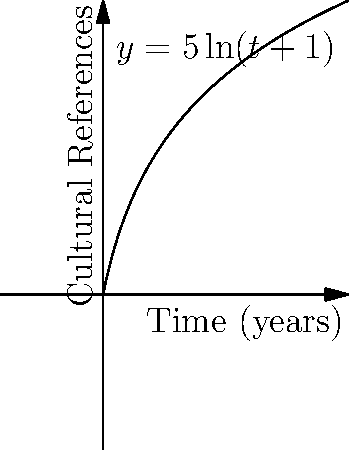In the context of film franchises, cultural references often accumulate over time. The function $y = 5\ln(t+1)$ represents the number of cultural references in a franchise, where $t$ is the time in years since the franchise's inception. Calculate the total accumulation of cultural references over the first 5 years of the franchise's existence. To find the total accumulation of cultural references over the first 5 years, we need to calculate the definite integral of the given function from $t=0$ to $t=5$.

1. The integral we need to evaluate is:
   $$\int_0^5 5\ln(t+1) dt$$

2. Let's use integration by parts. Let $u = \ln(t+1)$ and $dv = 5dt$.
   Then $du = \frac{1}{t+1}dt$ and $v = 5t$.

3. Applying the integration by parts formula:
   $$\int_0^5 5\ln(t+1) dt = 5t\ln(t+1)|_0^5 - \int_0^5 \frac{5t}{t+1} dt$$

4. Evaluate the first term:
   $5t\ln(t+1)|_0^5 = 5(5)\ln(6) - 5(0)\ln(1) = 25\ln(6)$

5. For the second integral, let $w = t+1$, so $dw = dt$:
   $$\int_0^5 \frac{5t}{t+1} dt = \int_1^6 5(w-1) dw = 5(w^2/2 - w)|_1^6$$
   
6. Evaluate:
   $5(w^2/2 - w)|_1^6 = 5((18 - 6) - (1/2 - 1)) = 5(12 + 1/2) = 62.5$

7. Combining the results:
   $25\ln(6) - 62.5$

8. This evaluates to approximately 27.24 cultural references.
Answer: 27.24 cultural references 